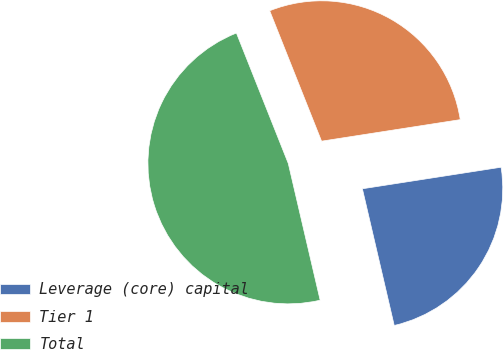Convert chart to OTSL. <chart><loc_0><loc_0><loc_500><loc_500><pie_chart><fcel>Leverage (core) capital<fcel>Tier 1<fcel>Total<nl><fcel>23.81%<fcel>28.57%<fcel>47.62%<nl></chart> 